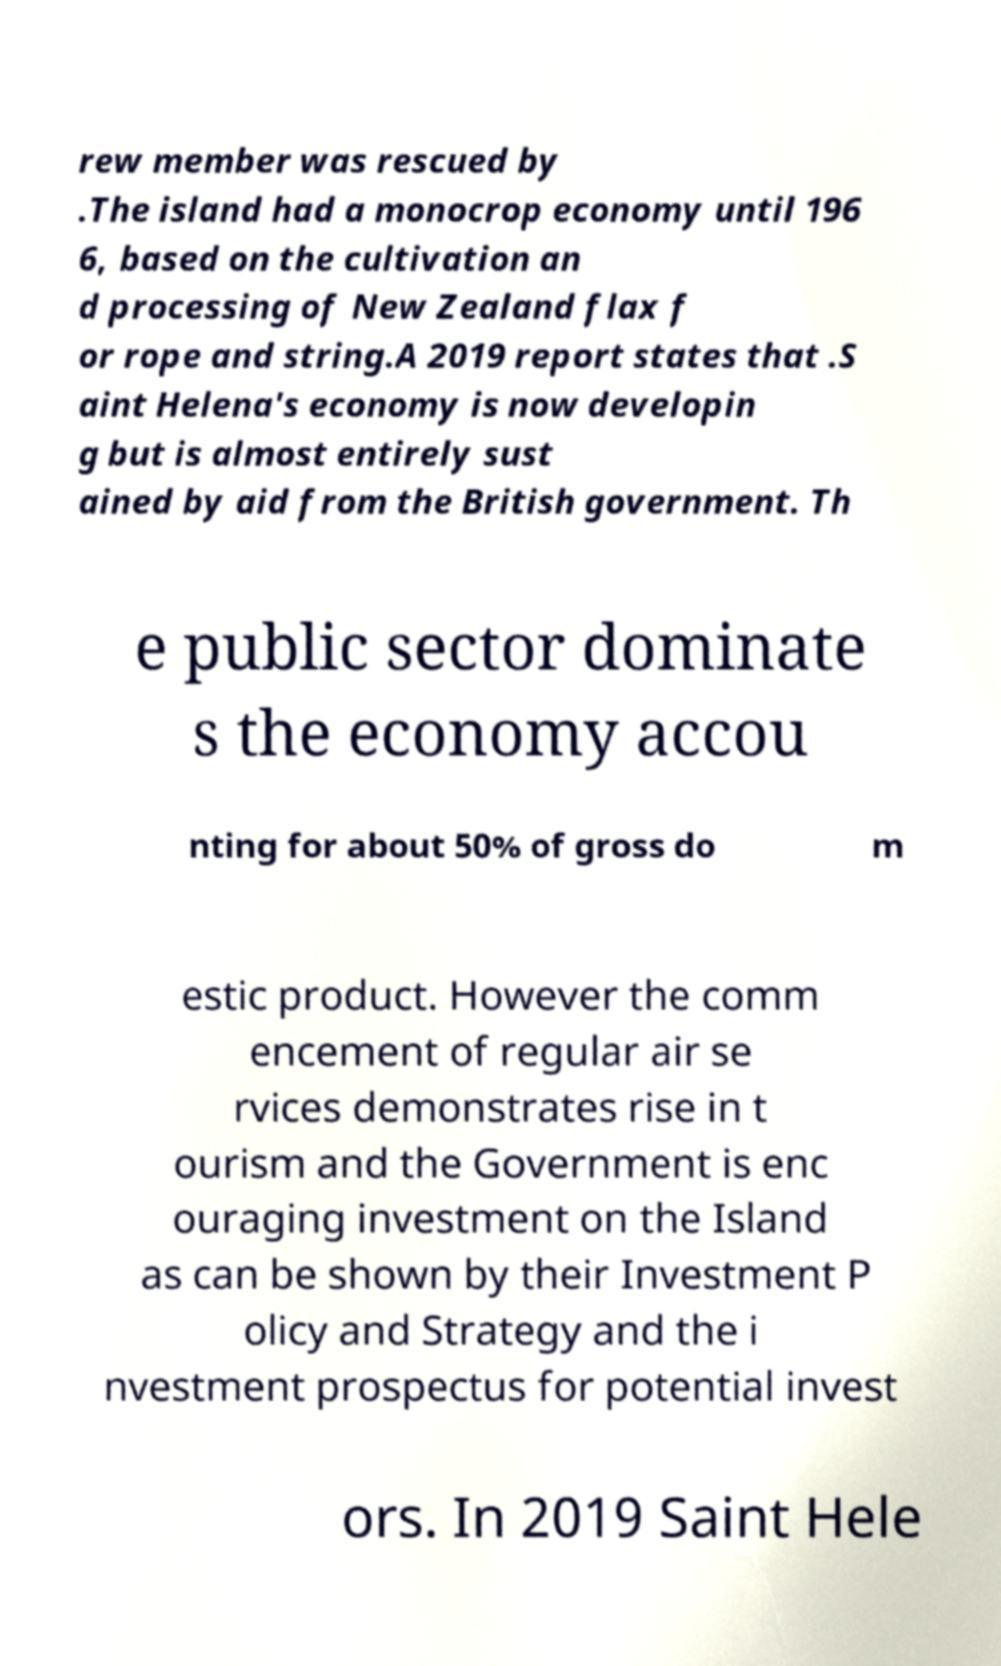I need the written content from this picture converted into text. Can you do that? rew member was rescued by .The island had a monocrop economy until 196 6, based on the cultivation an d processing of New Zealand flax f or rope and string.A 2019 report states that .S aint Helena's economy is now developin g but is almost entirely sust ained by aid from the British government. Th e public sector dominate s the economy accou nting for about 50% of gross do m estic product. However the comm encement of regular air se rvices demonstrates rise in t ourism and the Government is enc ouraging investment on the Island as can be shown by their Investment P olicy and Strategy and the i nvestment prospectus for potential invest ors. In 2019 Saint Hele 